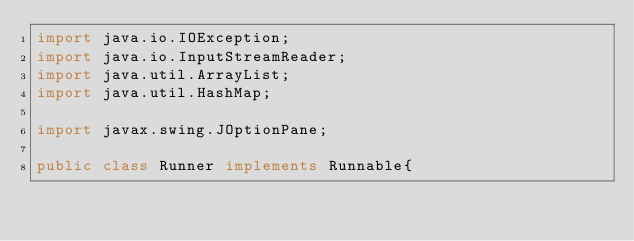<code> <loc_0><loc_0><loc_500><loc_500><_Java_>import java.io.IOException;
import java.io.InputStreamReader;
import java.util.ArrayList;
import java.util.HashMap;

import javax.swing.JOptionPane;

public class Runner implements Runnable{

	</code> 